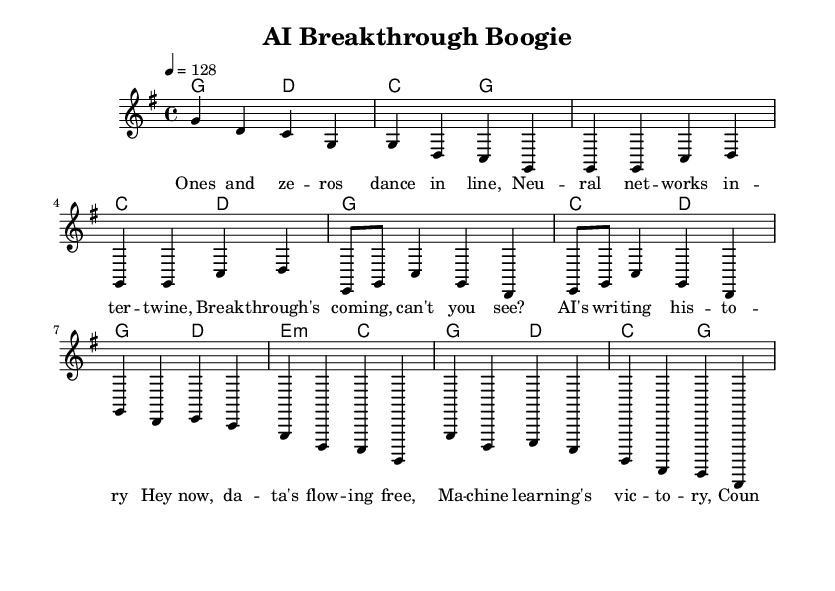What is the key signature of this music? The key signature is indicated by the number of sharps or flats at the beginning of the staff. In this case, it shows one sharp (F#), indicating G major.
Answer: G major What is the time signature of this music? The time signature is represented at the beginning of the score and is expressed as a fraction. Here, it shows 4/4, which means four beats per measure with the quarter note getting one beat.
Answer: 4/4 What is the tempo marking of this music? The tempo marking indicates the speed at which the music should be played. In this score, it is noted as "4 = 128", meaning there should be 128 beats per minute, with the quarter note getting one beat.
Answer: 128 What chord follows the first measure of the chorus? The chord progression in the chorus is shown in the harmonies section, where the first measure of the chorus is G major, following the introduction. This means the chord performed after the measure is G.
Answer: G How many lines are there in the verse lyrics? The verse lyrics contain specific phrases that are placed on a musical staff. Counting the distinct lines of lyrics provided in the verse, there are four lines that convey the complete thought.
Answer: Four What thematic element is celebrated in the song? Analyzing the lyrics in the chorus expresses clear themes surrounding breakthroughs in AI and technology. The lyrics mention data flow and machine learning, suggesting the overall theme centers on advancements in these areas.
Answer: Advancements in AI What unique feature characterizes the music type "Country Rock"? Country rock often blends elements of traditional country music with rock influences, usually featuring a strong emphasis on guitar riffs, harmonies, and a rhythm that encourages dancing. The uplifting and celebratory nature of the lyrics also reflects this blend.
Answer: Celebration and upbeat tempo 